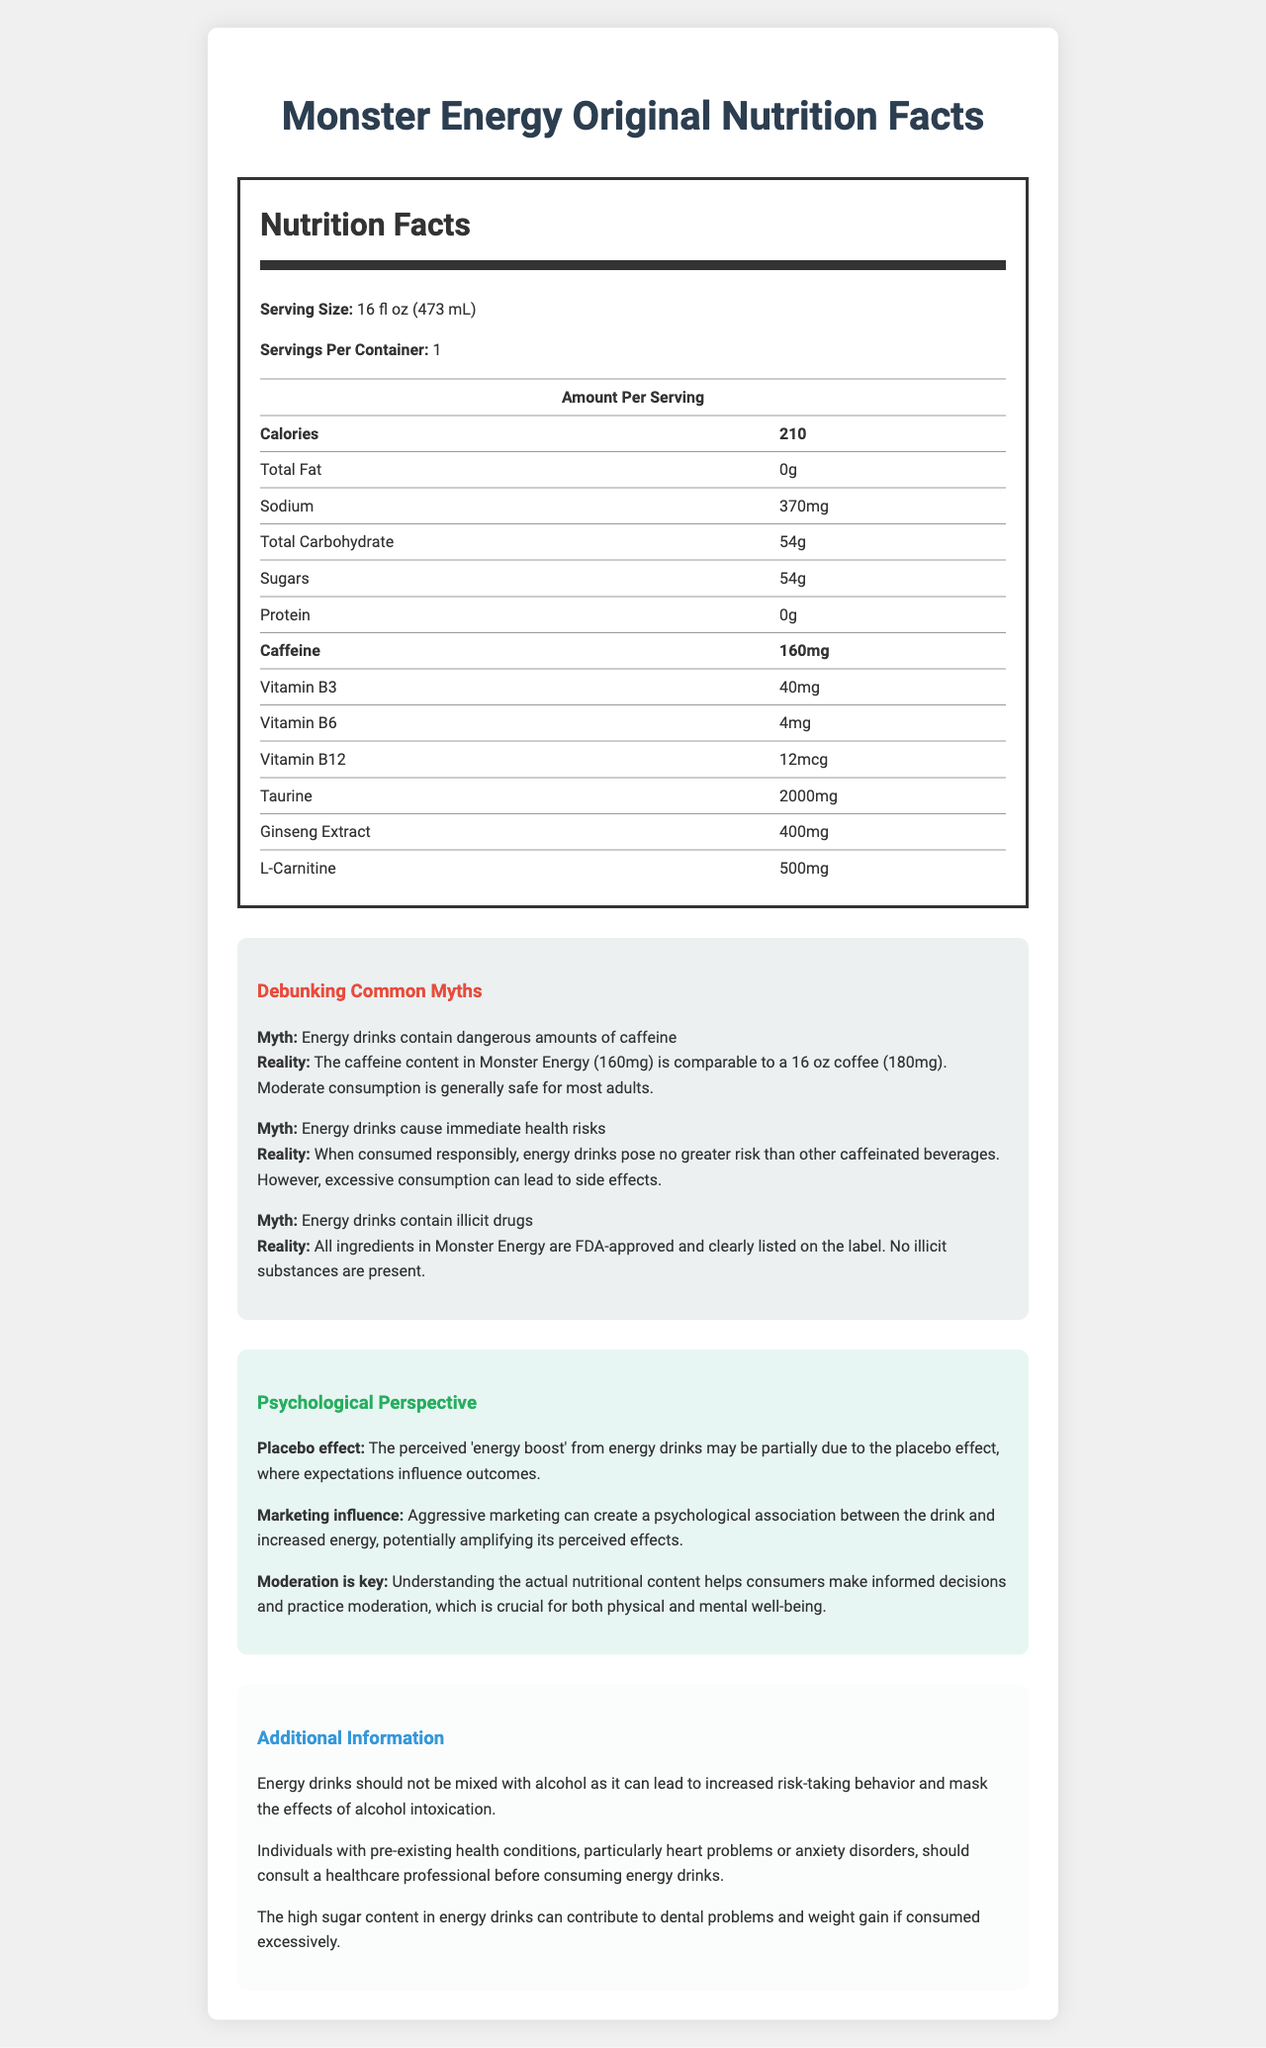what is the caffeine content in Monster Energy Original? The label explicitly states that the caffeine content per serving is 160mg.
Answer: 160mg how many servings are in one container? The label specifies that there is 1 serving per container.
Answer: 1 what is the total carbohydrate content? The label indicates that total carbohydrates per serving are 54g.
Answer: 54g how many calories are there per serving? According to the label, there are 210 calories per serving.
Answer: 210 what is the amount of sodium in this energy drink? The nutrition facts label states that the sodium content per serving is 370mg.
Answer: 370mg which vitamin is present in the smallest quantity in Monster Energy Original? A. Vitamin B3 B. Vitamin B6 C. Vitamin B12 According to the label, Vitamin B12 is present in the smallest quantity at 12mcg.
Answer: C. Vitamin B12 which ingredient is present in the largest quantity? A. Taurine B. Ginseng Extract C. L-Carnitine The label states that taurine is present in the largest quantity at 2000mg.
Answer: A. Taurine is the statement "Energy drinks contain dangerous amounts of caffeine" true or false? The debunked myth section states that the caffeine content in Monster Energy (160mg) is comparable to a 16 oz coffee (180mg) and is generally safe for moderate consumption.
Answer: False does the document provide a psychological perspective on energy drink consumption? The psychological perspective section discusses the placebo effect, marketing influence, and the importance of moderation.
Answer: Yes summarize the main points of the document. The document is designed to inform consumers about the contents and potential effects of Monster Energy Original, address common misconceptions, and highlight important consumption tips.
Answer: The document provides nutritional information for Monster Energy Original, including calorie, caffeine, vitamin, and ingredient content. It debunks myths about energy drinks, presents a psychological perspective on their consumption, and gives additional information like health precautions and effects of mixing with alcohol. what are the potential risks of mixing energy drinks with alcohol? The additional information section states that mixing energy drinks with alcohol can lead to increased risk-taking behavior and mask the effects of alcohol intoxication.
Answer: Increased risk-taking behavior and masking the effects of alcohol intoxication does Monster Energy Original contain any illicit substances? The debunked myths section clarifies that all ingredients in Monster Energy are FDA-approved and clearly listed on the label, with no illicit substances present.
Answer: No how much Vitamin B6 is in Monster Energy Original? The nutrition facts label lists the Vitamin B6 content as 4mg per serving.
Answer: 4mg what is the role of marketing in the perceived effects of energy drinks? The psychological perspective section includes information about the influence of marketing on consumers' perceptions.
Answer: Marketing creates a psychological association between the drink and increased energy, potentially amplifying its perceived effects what should individuals with heart problems do before consuming energy drinks? The additional information section advises individuals with pre-existing health conditions, particularly heart problems, to consult a healthcare professional before consuming energy drinks.
Answer: Consult a healthcare professional is the ingredient taurine higher in quantity than caffeine in this drink? The nutrition facts label shows taurine at 2000mg, which is significantly higher than the caffeine content of 160mg.
Answer: Yes how does the placebo effect relate to energy drink consumption? The psychological perspective section discusses the placebo effect and how it affects consumers' perception of energy drinks.
Answer: The placebo effect may contribute to the perceived 'energy boost' from energy drinks as expectations influence outcomes does Monster Energy Original have protein content? The nutrition facts label indicates that the protein content is 0g.
Answer: No is there enough information to determine whether Monster Energy Original is suitable for diabetics? The document does not provide specific information regarding the suitability of Monster Energy Original for individuals with diabetes.
Answer: Not enough information 